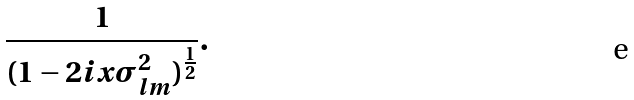<formula> <loc_0><loc_0><loc_500><loc_500>\frac { 1 } { ( 1 - 2 i x \sigma _ { l m } ^ { 2 } ) ^ { \frac { 1 } { 2 } } } .</formula> 